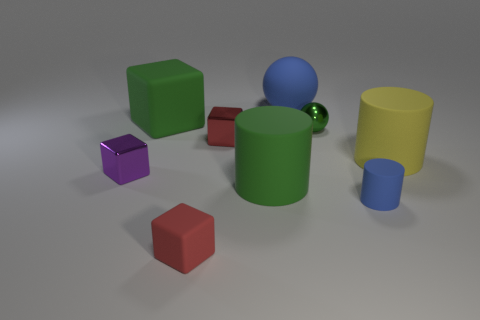Subtract all green rubber blocks. How many blocks are left? 3 Subtract all purple balls. How many red blocks are left? 2 Subtract all green cubes. How many cubes are left? 3 Subtract all cylinders. How many objects are left? 6 Subtract all brown blocks. Subtract all purple balls. How many blocks are left? 4 Subtract all tiny red cylinders. Subtract all yellow rubber things. How many objects are left? 8 Add 9 red shiny blocks. How many red shiny blocks are left? 10 Add 1 big yellow things. How many big yellow things exist? 2 Subtract 0 red spheres. How many objects are left? 9 